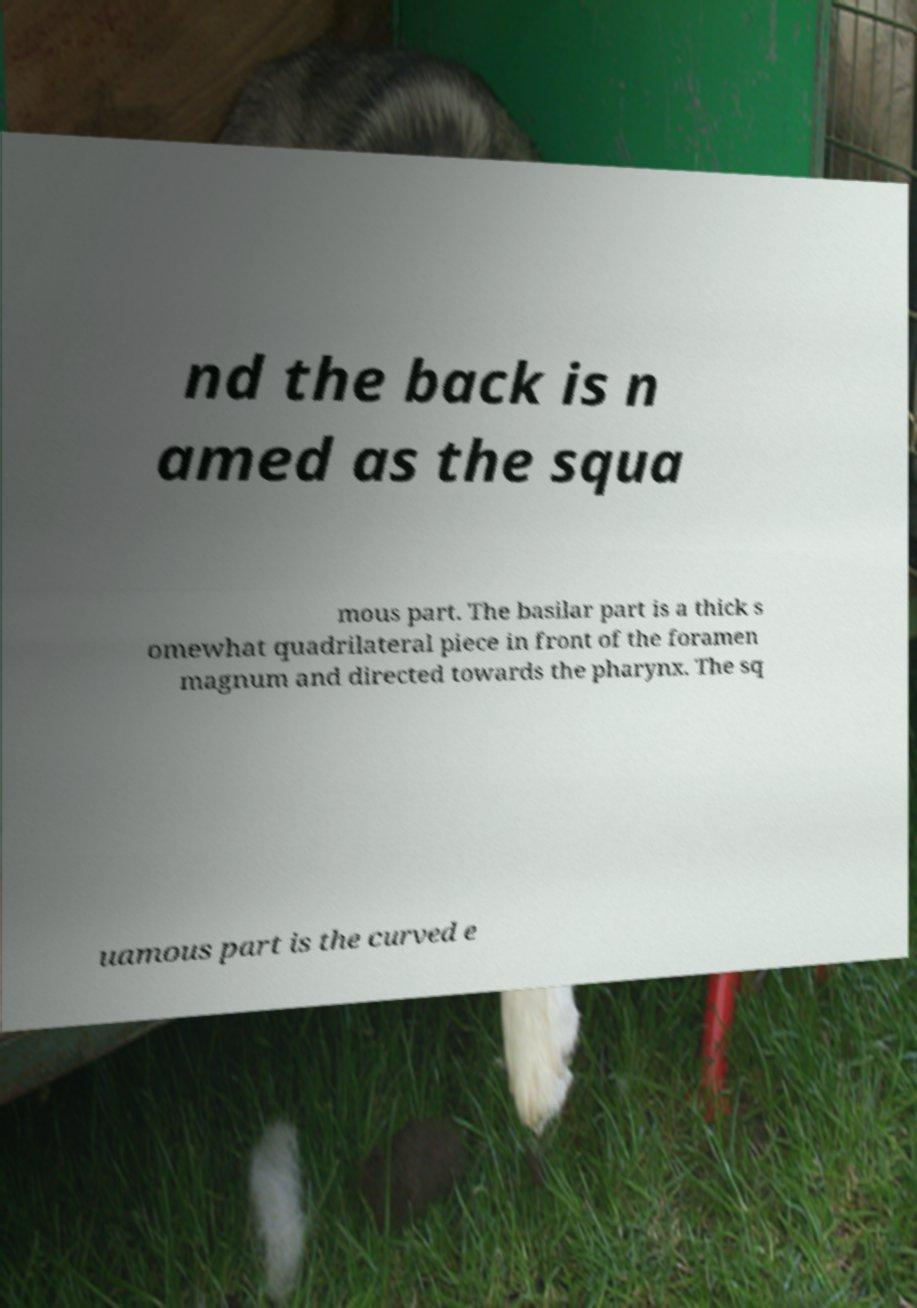Can you accurately transcribe the text from the provided image for me? nd the back is n amed as the squa mous part. The basilar part is a thick s omewhat quadrilateral piece in front of the foramen magnum and directed towards the pharynx. The sq uamous part is the curved e 